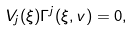Convert formula to latex. <formula><loc_0><loc_0><loc_500><loc_500>V _ { j } ( \xi ) \Gamma ^ { j } ( \xi , v ) = 0 ,</formula> 